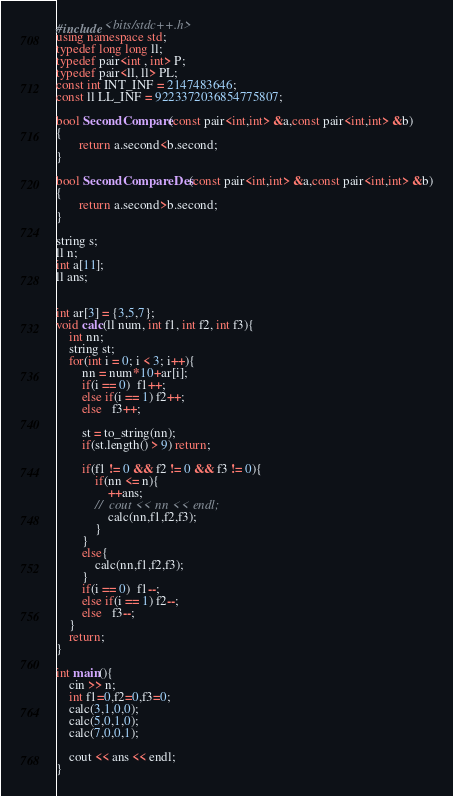<code> <loc_0><loc_0><loc_500><loc_500><_C++_>#include <bits/stdc++.h>
using namespace std;
typedef long long ll;
typedef pair<int , int> P;
typedef pair<ll, ll> PL;
const int INT_INF = 2147483646;
const ll LL_INF = 9223372036854775807;

bool SecondCompare(const pair<int,int> &a,const pair<int,int> &b)
{
       return a.second<b.second;
}
 
bool SecondCompareDes(const pair<int,int> &a,const pair<int,int> &b)
{
       return a.second>b.second;
}
 
string s;
ll n;
int a[11];
ll ans;


int ar[3] = {3,5,7};
void calc(ll num, int f1, int f2, int f3){
    int nn;
    string st;
    for(int i = 0; i < 3; i++){
        nn = num*10+ar[i];
        if(i == 0)  f1++;
        else if(i == 1) f2++;
        else   f3++;

        st = to_string(nn);
        if(st.length() > 9) return;

        if(f1 != 0 && f2 != 0 && f3 != 0){
            if(nn <= n){
                ++ans;
            //  cout << nn << endl;
                calc(nn,f1,f2,f3);
            }
        }
        else{
            calc(nn,f1,f2,f3);
        }
        if(i == 0)  f1--;
        else if(i == 1) f2--;
        else   f3--;
    }
    return;
}

int main(){
    cin >> n;
    int f1=0,f2=0,f3=0;
    calc(3,1,0,0);
    calc(5,0,1,0);
    calc(7,0,0,1);

    cout << ans << endl;
}</code> 